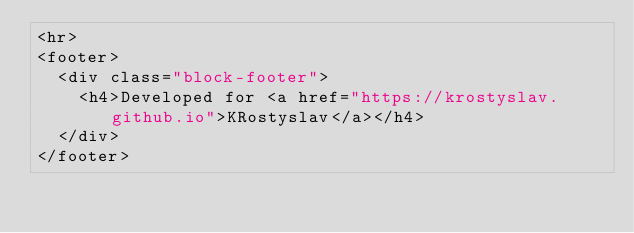Convert code to text. <code><loc_0><loc_0><loc_500><loc_500><_HTML_><hr>
<footer>
  <div class="block-footer">
    <h4>Developed for <a href="https://krostyslav.github.io">KRostyslav</a></h4>
  </div>
</footer>
</code> 